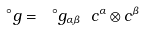Convert formula to latex. <formula><loc_0><loc_0><loc_500><loc_500>\ ^ { \circ } g = \ ^ { \circ } g _ { \alpha \beta } \ c ^ { \alpha } \otimes c ^ { \beta }</formula> 